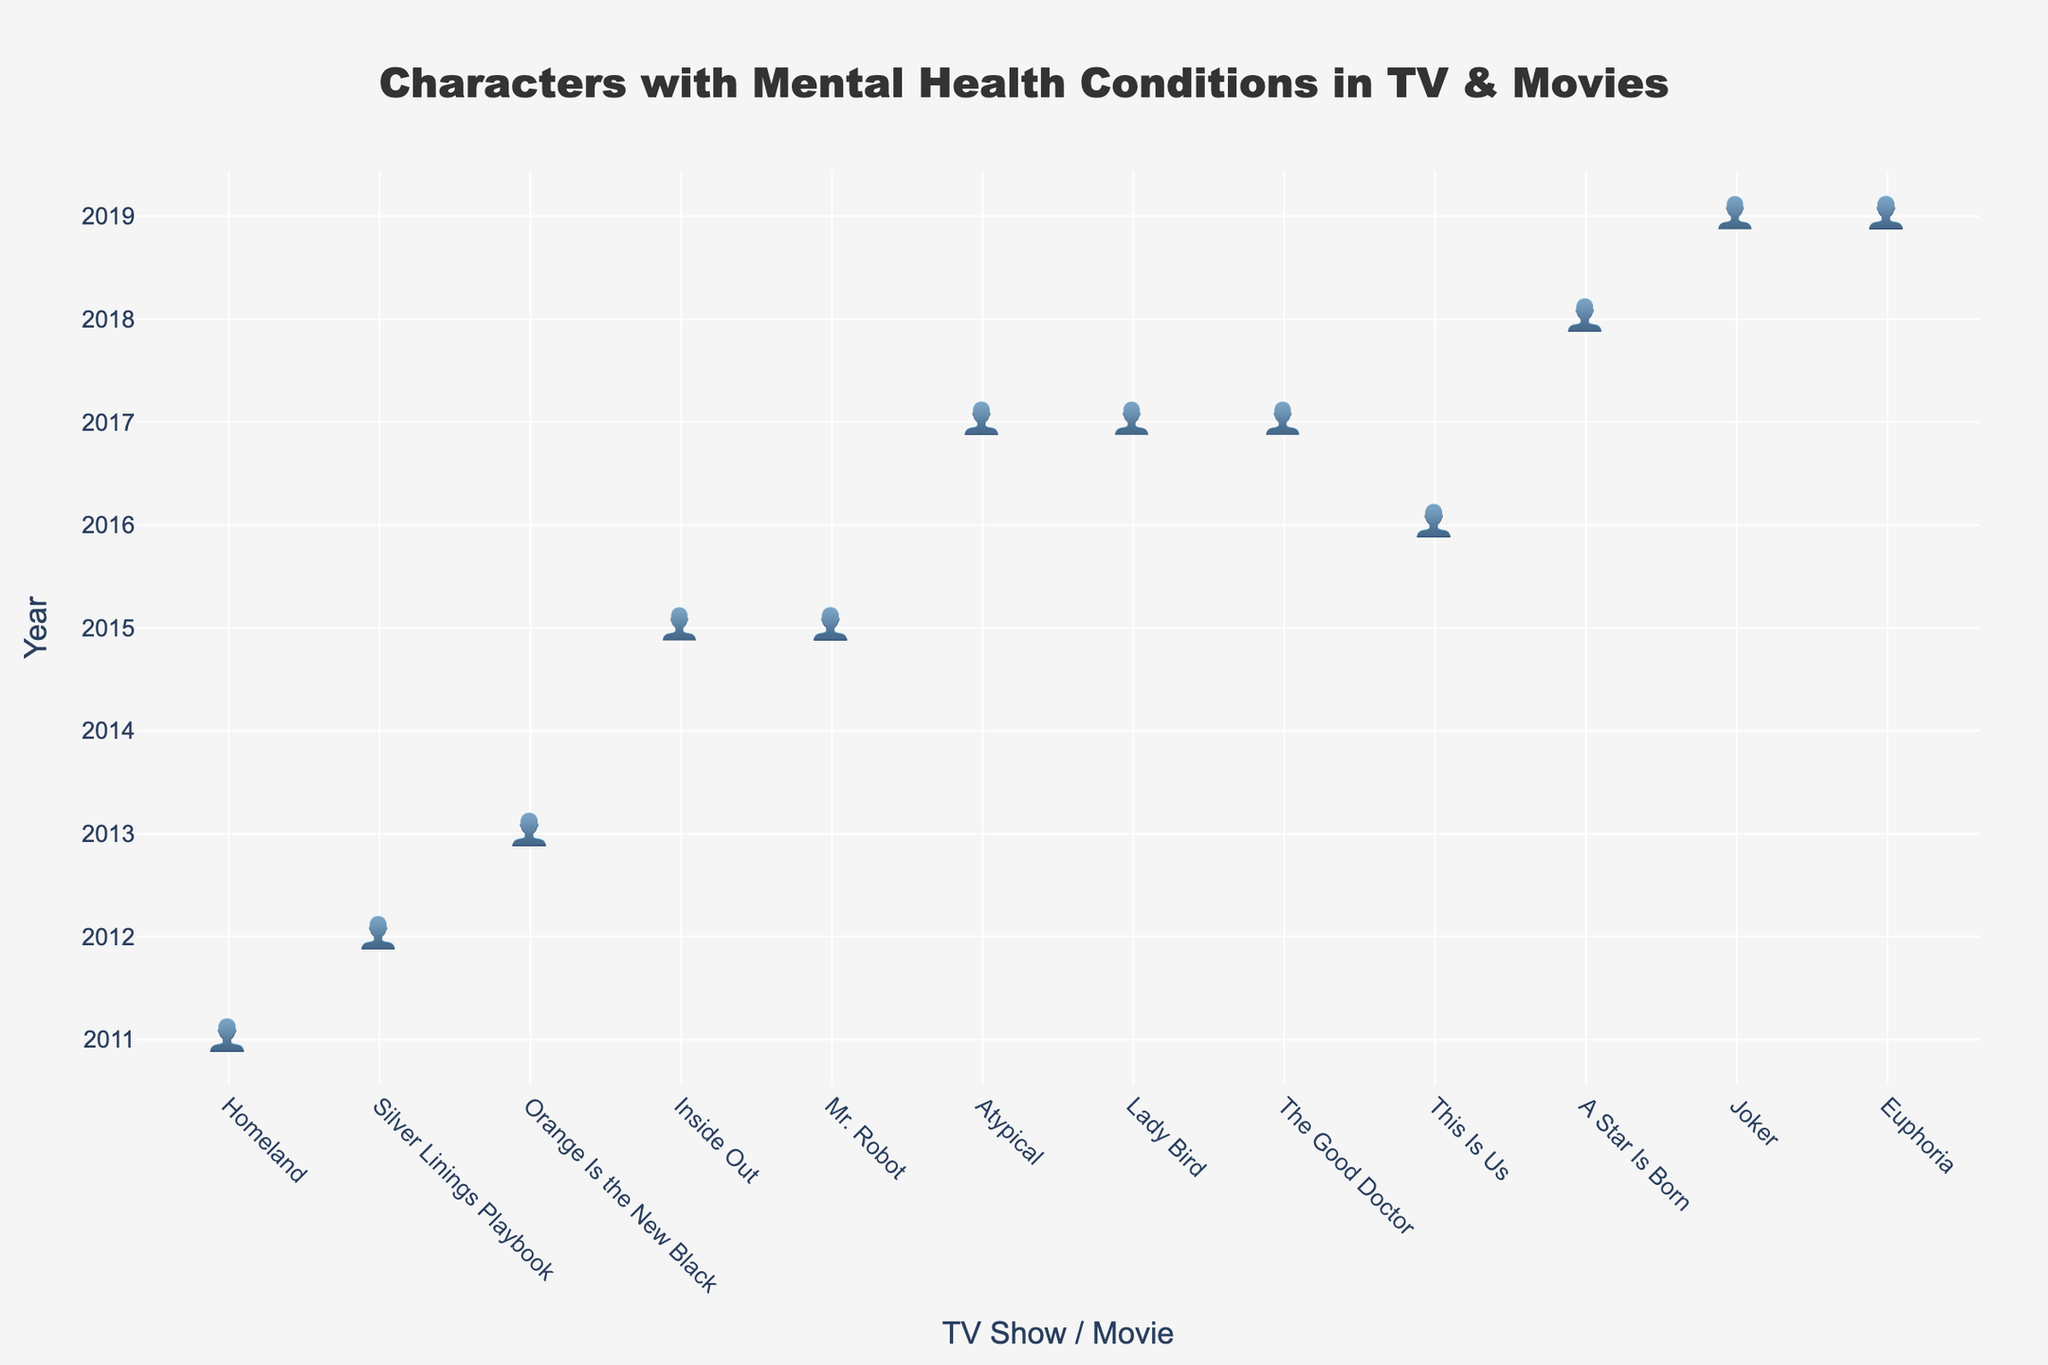What's the title of the plot? The title is found at the top of the plot, generally formatted in a larger and bolder font compared to other text elements.
Answer: Characters with Mental Health Conditions in TV & Movies How many characters with mental health conditions are depicted in 2019? Look at the y-axis for the year 2019, and count the number of character icons ('👤') shown.
Answer: 5 Which year has the highest number of representations of characters with mental health conditions? Find the year along the y-axis that has the most character icons ('👤').
Answer: 2011 Compare the number of characters in 'Euphoria' with 'This Is Us'. Which one has more? Find 'Euphoria' and 'This Is Us' along the x-axis and count the number of character icons ('👤') for each. Compare the counts.
Answer: Euphoria How many characters with mental health conditions are represented in 2017? Find the year 2017 on the y-axis and count all the character icons ('👤') across the TV shows and movies listed under this year.
Answer: 4 Are there any TV shows or movies from 2015 depicted in the plot? Look at the year 2015 along the y-axis and check for any corresponding TV shows or movies along the x-axis.
Answer: Yes Which TV show or movie has the lowest representation of characters with mental health conditions and in which year was it released? Find the TV show or movie along the x-axis that has the least number of character icons ('👤'). Note its name and corresponding year along the y-axis.
Answer: Inside Out, 2015 What is the total number of characters with mental health conditions across all TV shows and movies? Sum up the number of character icons ('👤') from each TV show and movie along the x-axis.
Answer: 29 Which year had the same number of characters with mental health conditions in 'A Star Is Born' and another TV show or movie? Identify 'A Star Is Born' along the x-axis and then find the corresponding year. Check other TV shows or movies in that same year to see if any have the same number of character icons ('👤').
Answer: 2018 